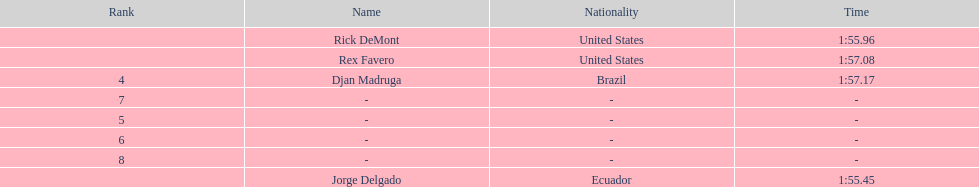Favero finished in 1:57.08. what was the next time? 1:57.17. 